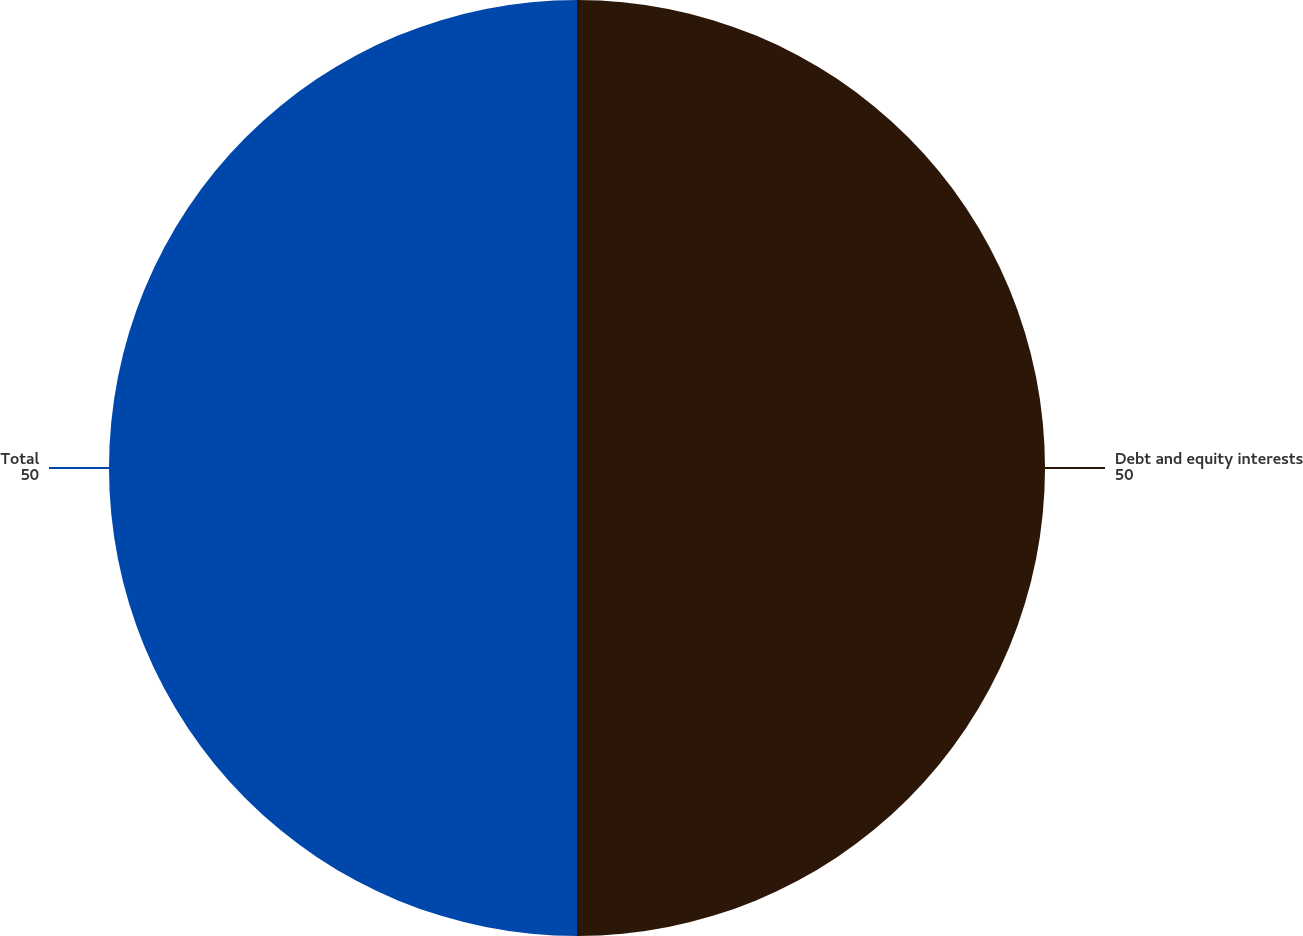Convert chart to OTSL. <chart><loc_0><loc_0><loc_500><loc_500><pie_chart><fcel>Debt and equity interests<fcel>Total<nl><fcel>50.0%<fcel>50.0%<nl></chart> 